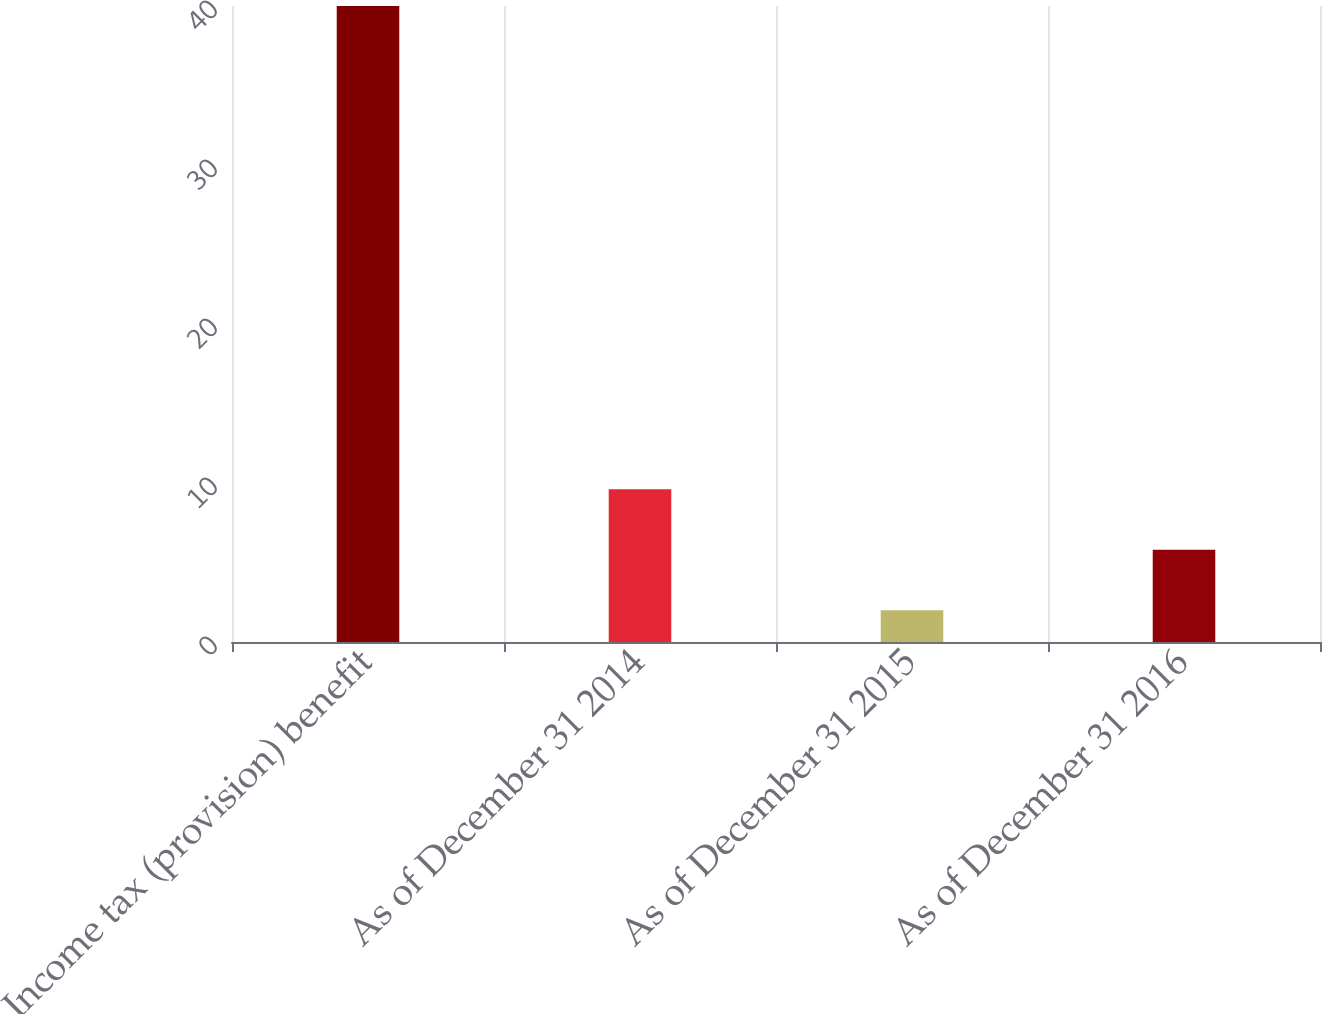Convert chart. <chart><loc_0><loc_0><loc_500><loc_500><bar_chart><fcel>Income tax (provision) benefit<fcel>As of December 31 2014<fcel>As of December 31 2015<fcel>As of December 31 2016<nl><fcel>40<fcel>9.6<fcel>2<fcel>5.8<nl></chart> 